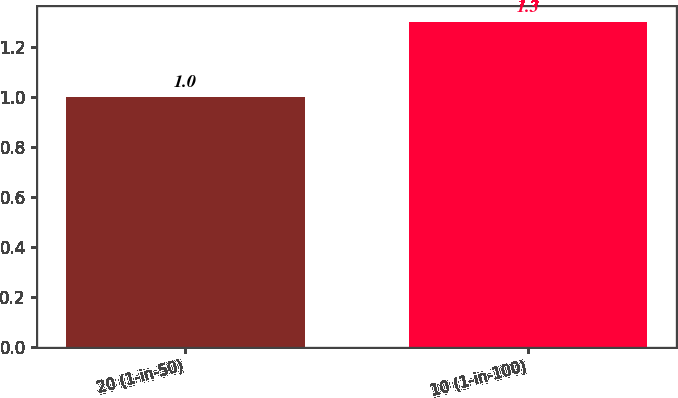Convert chart to OTSL. <chart><loc_0><loc_0><loc_500><loc_500><bar_chart><fcel>20 (1-in-50)<fcel>10 (1-in-100)<nl><fcel>1<fcel>1.3<nl></chart> 